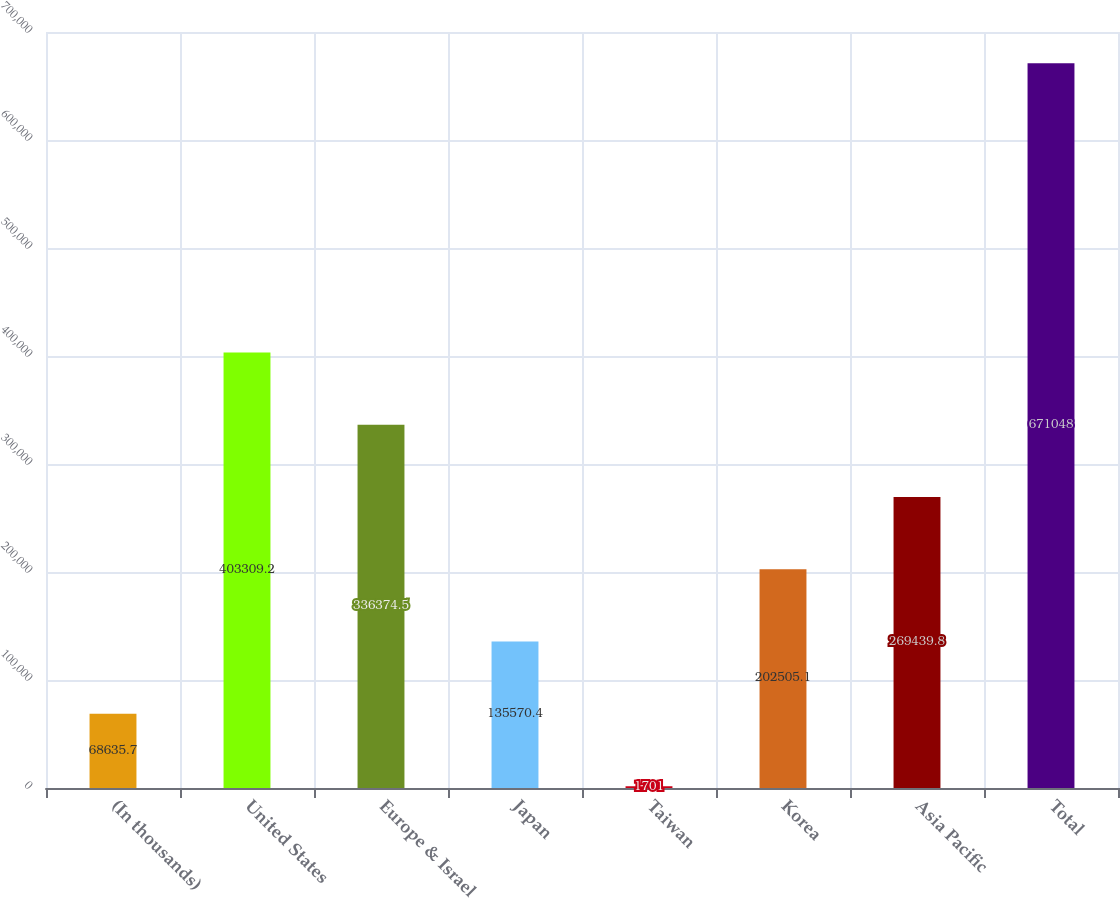Convert chart to OTSL. <chart><loc_0><loc_0><loc_500><loc_500><bar_chart><fcel>(In thousands)<fcel>United States<fcel>Europe & Israel<fcel>Japan<fcel>Taiwan<fcel>Korea<fcel>Asia Pacific<fcel>Total<nl><fcel>68635.7<fcel>403309<fcel>336374<fcel>135570<fcel>1701<fcel>202505<fcel>269440<fcel>671048<nl></chart> 